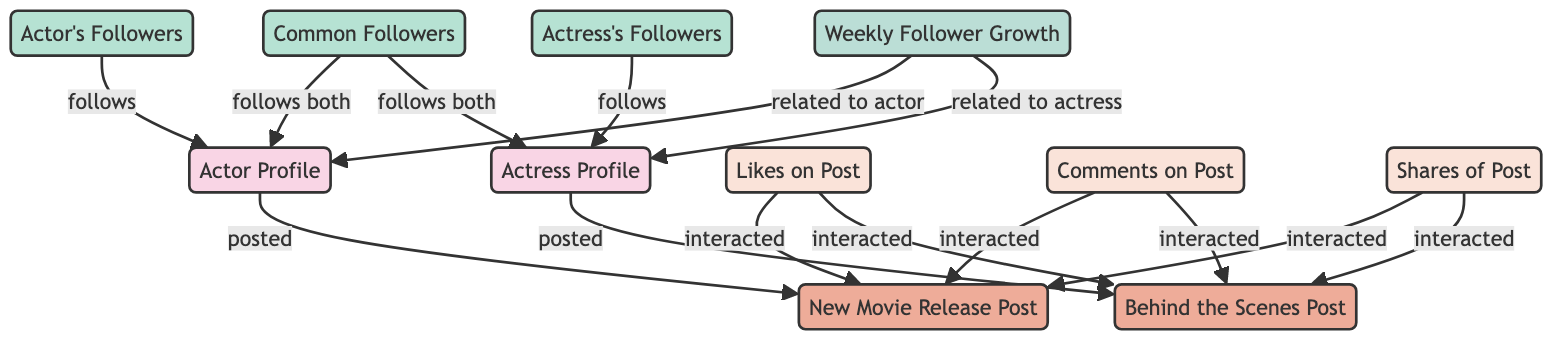What are the types of profiles present in the diagram? The diagram features two types of profiles: "Actor Profile" and "Actress Profile," which are categorized as person nodes.
Answer: person How many posts are represented in the diagram? There are two posts in the diagram, identified as "New Movie Release Post" and "Behind the Scenes Post."
Answer: 2 Who posted the "Behind the Scenes Post"? The "Behind the Scenes Post" was posted by the "Actress Profile," as indicated by the directed edge labeled "posted" from "actress_profile" to "post_2."
Answer: Actress Profile What is the relationship between "common followers" and the "actor profile"? The "common followers" follows the "actor profile," which is shown by the directed edge labeled "follows both" connecting "common_followers" to "actor_profile."
Answer: follows both Which interactions are associated with the "New Movie Release Post"? The "New Movie Release Post" is associated with three interactions: likes, comments, and shares, as indicated by edges leading from interaction nodes to "post_1."
Answer: likes, comments, shares Which actress's followers also interact with the actor's posts? "Common Followers" interact with both the "Actor Profile" and the "Actress Profile," as seen from the nodes linked to both profiles.
Answer: Common Followers What is the connection between weekly follower growth and both profiles? The "Weekly Follower Growth" node has directed edges indicating it is related to both the "actor profile" and the "actress profile," showing shared growth influences.
Answer: related to actor and related to actress How many interactions are represented in relation to both posts? The diagram contains three types of interactions (likes, comments, and shares) for each post, leading to a total of six interactions.
Answer: 6 What kind of nodes represent followers in the diagram? The diagram features three group nodes representing followers: "Actor's Followers," "Actress's Followers," and "Common Followers."
Answer: group 